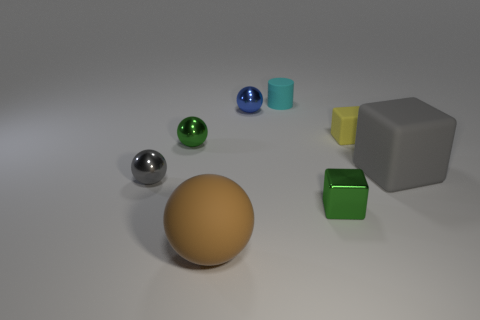Subtract 1 balls. How many balls are left? 3 Add 1 green spheres. How many objects exist? 9 Subtract all blocks. How many objects are left? 5 Add 5 cyan blocks. How many cyan blocks exist? 5 Subtract 0 red cubes. How many objects are left? 8 Subtract all tiny green spheres. Subtract all yellow matte things. How many objects are left? 6 Add 7 yellow rubber things. How many yellow rubber things are left? 8 